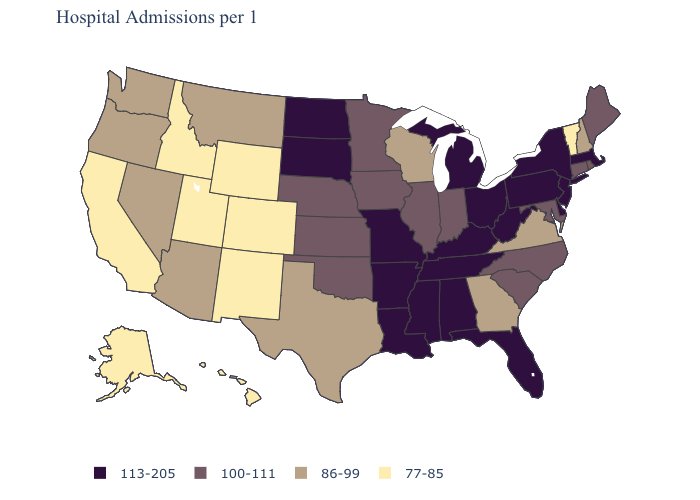What is the lowest value in the South?
Quick response, please. 86-99. How many symbols are there in the legend?
Short answer required. 4. What is the lowest value in the West?
Short answer required. 77-85. What is the highest value in the USA?
Answer briefly. 113-205. What is the value of Montana?
Quick response, please. 86-99. What is the highest value in the USA?
Write a very short answer. 113-205. Does Georgia have the lowest value in the South?
Quick response, please. Yes. Among the states that border Michigan , which have the highest value?
Give a very brief answer. Ohio. What is the value of Washington?
Quick response, please. 86-99. What is the value of Alaska?
Answer briefly. 77-85. Which states have the lowest value in the USA?
Write a very short answer. Alaska, California, Colorado, Hawaii, Idaho, New Mexico, Utah, Vermont, Wyoming. Does Tennessee have the same value as New York?
Give a very brief answer. Yes. Name the states that have a value in the range 86-99?
Quick response, please. Arizona, Georgia, Montana, Nevada, New Hampshire, Oregon, Texas, Virginia, Washington, Wisconsin. Among the states that border Minnesota , which have the highest value?
Be succinct. North Dakota, South Dakota. Does Connecticut have a higher value than Utah?
Concise answer only. Yes. 